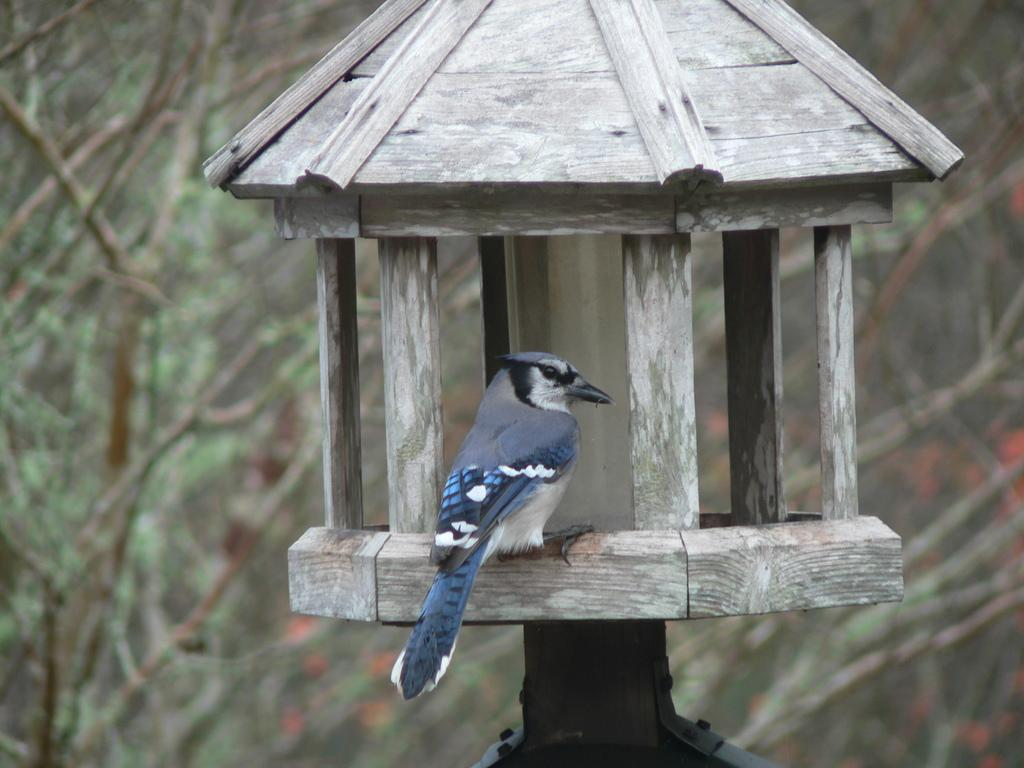What is there are many trees visible in the image. What else can be seen? In addition to the trees, there is a lamp in the image. Can you describe the lamp in more detail? Yes, there is a bird sitting on the wooden surface of the lamp. What type of apparel is the bird wearing while sitting on the lamp? The bird is not wearing any apparel in the image. Can you tell me how many pickles are on the lamp? There are no pickles present in the image; it features a bird sitting on a lamp. Is there a kettle visible in the image? No, there is no kettle visible in the image. 